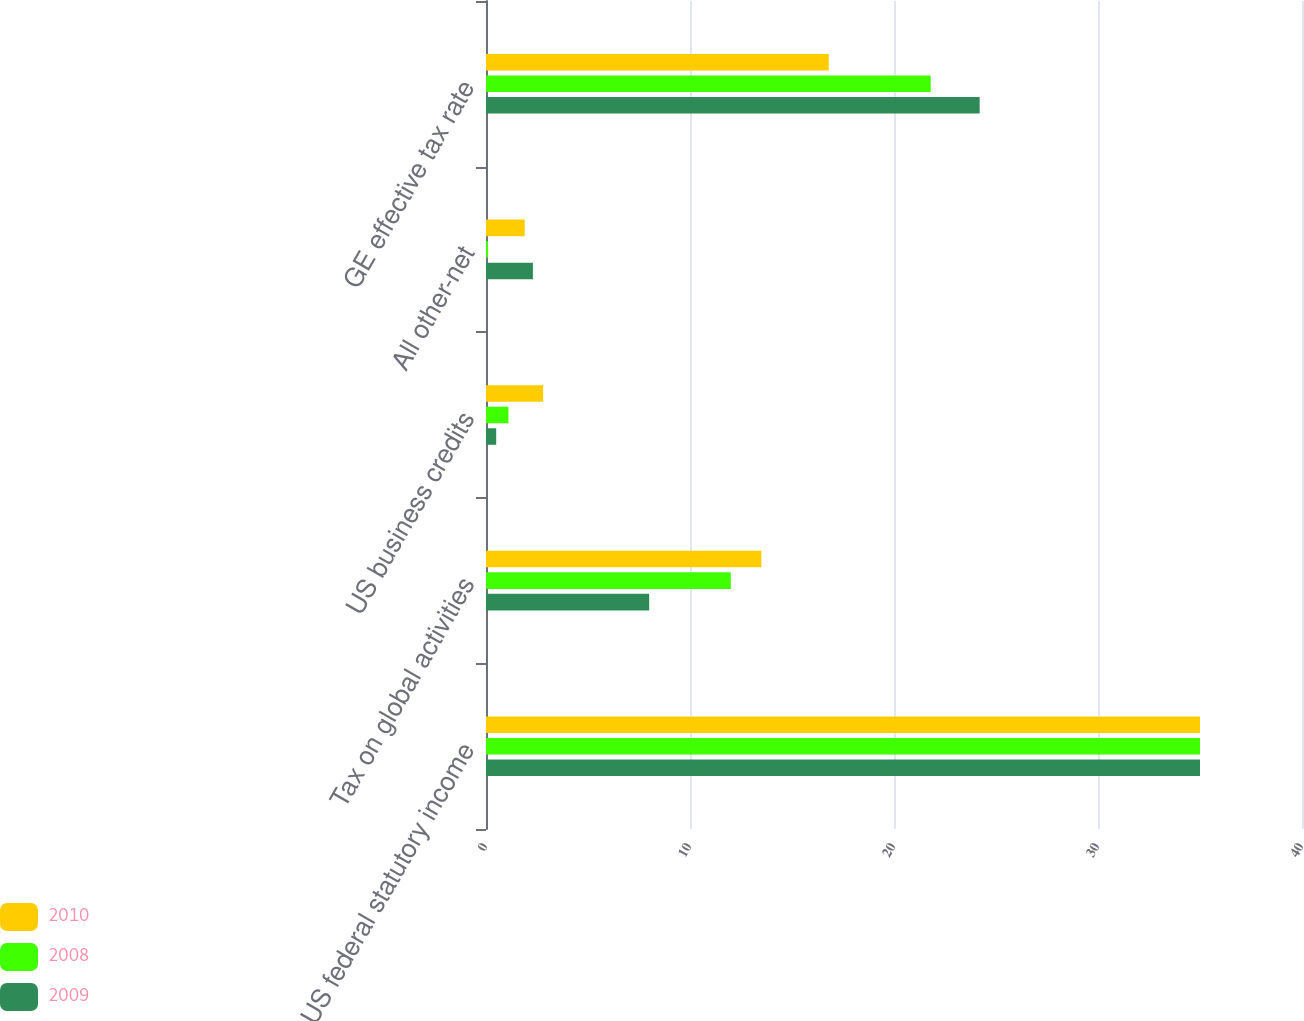Convert chart. <chart><loc_0><loc_0><loc_500><loc_500><stacked_bar_chart><ecel><fcel>US federal statutory income<fcel>Tax on global activities<fcel>US business credits<fcel>All other-net<fcel>GE effective tax rate<nl><fcel>2010<fcel>35<fcel>13.5<fcel>2.8<fcel>1.9<fcel>16.8<nl><fcel>2008<fcel>35<fcel>12<fcel>1.1<fcel>0.1<fcel>21.8<nl><fcel>2009<fcel>35<fcel>8<fcel>0.5<fcel>2.3<fcel>24.2<nl></chart> 